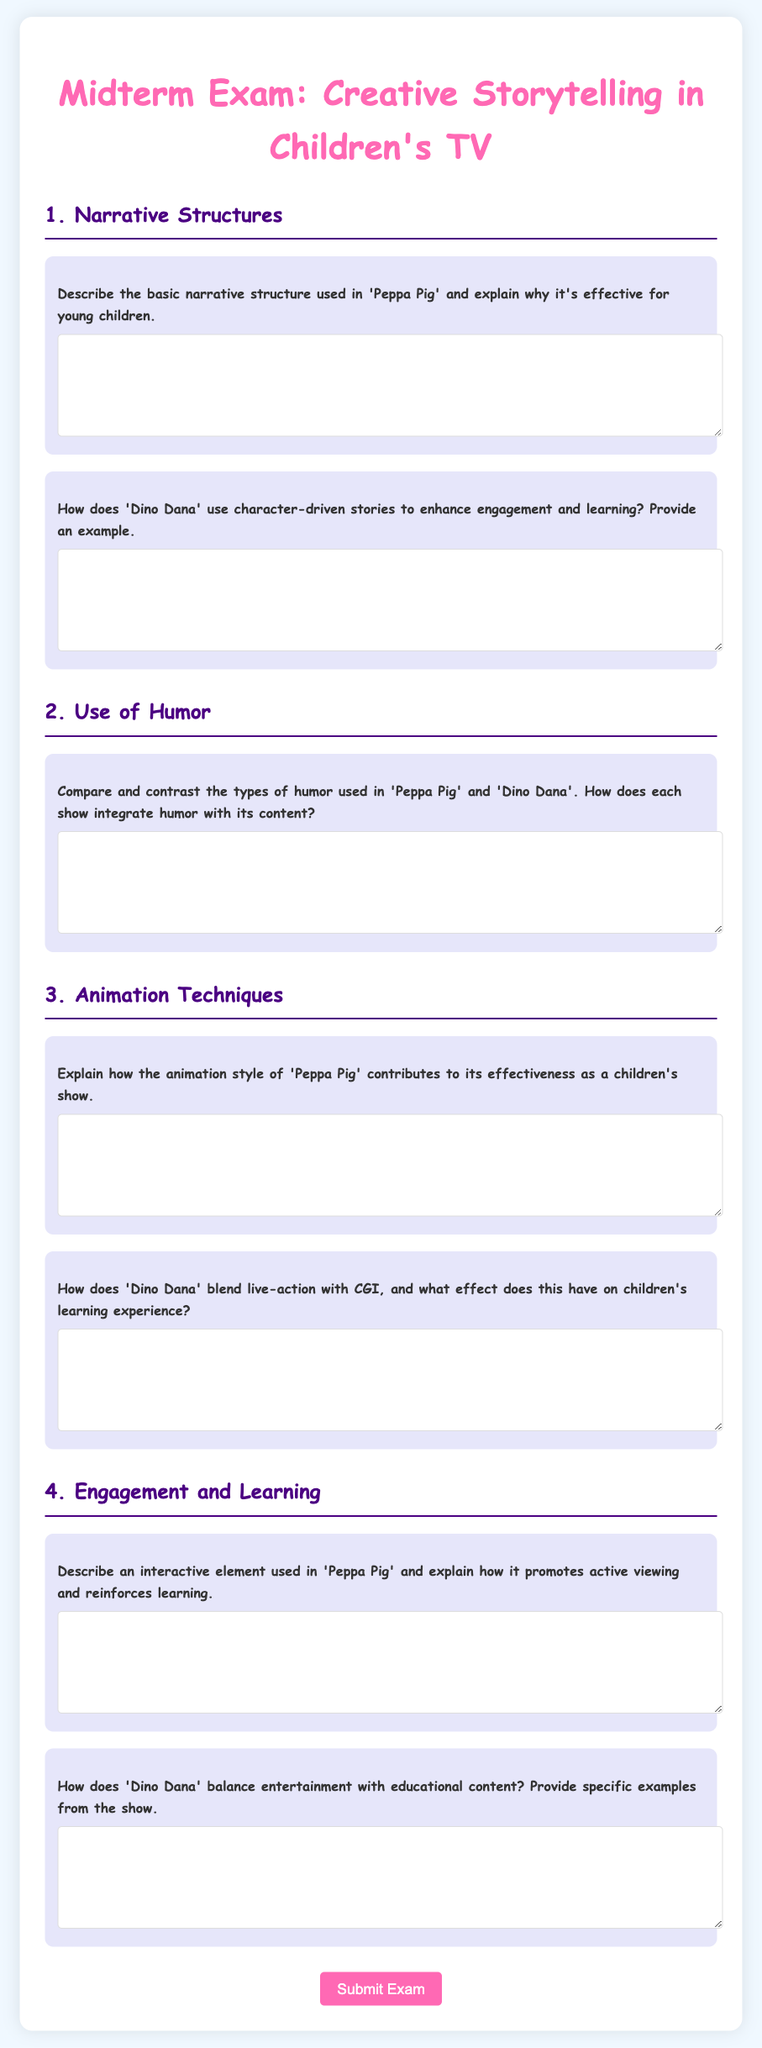What is the title of the document? The title of the document is located in the header section of the HTML and specifies the content of the midterm exam.
Answer: Midterm Exam: Creative Storytelling in Children's TV How many sections are there in the exam? The document contains four major sections, each represented by a numbered heading (1 through 4).
Answer: 4 What color is used for the headings in the document? The color for the headings is specified in the CSS styles, indicating the visual theme of the exam.
Answer: #ff69b4 for the main heading and #4b0082 for subheadings What is the first question in the Narrative Structures section? The first question asks about the basic narrative structure of 'Peppa Pig' and its effectiveness, directly referencing the content of that section.
Answer: Describe the basic narrative structure used in 'Peppa Pig' and explain why it's effective for young children What interactive element is mentioned in the Engagement and Learning section? The document specifically asks about an interactive element used in 'Peppa Pig', indicating the focus of that question.
Answer: An interactive element used in 'Peppa Pig' How does 'Dino Dana' enhance engagement? The document contains a question asking how 'Dino Dana' uses character-driven stories, focusing on its engagement strategies.
Answer: By using character-driven stories What type of animation does 'Peppa Pig' utilize? The question in the Animation Techniques section asks about the animation style of 'Peppa Pig'.
Answer: Animation style of 'Peppa Pig' How does humor function in these children's shows? The document has a question comparing the humor in 'Peppa Pig' and 'Dino Dana', indicating the role of humor in their narratives.
Answer: Integrates humor with its content What aspect of 'Dino Dana' is blended with CGI? There is a question about how 'Dino Dana' combines live-action with CGI, referring to a specific technique in the show.
Answer: Live-action with CGI 